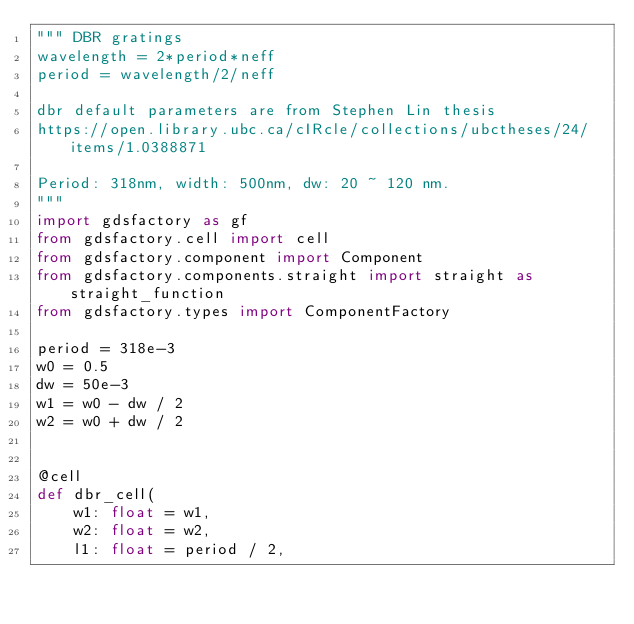<code> <loc_0><loc_0><loc_500><loc_500><_Python_>""" DBR gratings
wavelength = 2*period*neff
period = wavelength/2/neff

dbr default parameters are from Stephen Lin thesis
https://open.library.ubc.ca/cIRcle/collections/ubctheses/24/items/1.0388871

Period: 318nm, width: 500nm, dw: 20 ~ 120 nm.
"""
import gdsfactory as gf
from gdsfactory.cell import cell
from gdsfactory.component import Component
from gdsfactory.components.straight import straight as straight_function
from gdsfactory.types import ComponentFactory

period = 318e-3
w0 = 0.5
dw = 50e-3
w1 = w0 - dw / 2
w2 = w0 + dw / 2


@cell
def dbr_cell(
    w1: float = w1,
    w2: float = w2,
    l1: float = period / 2,</code> 